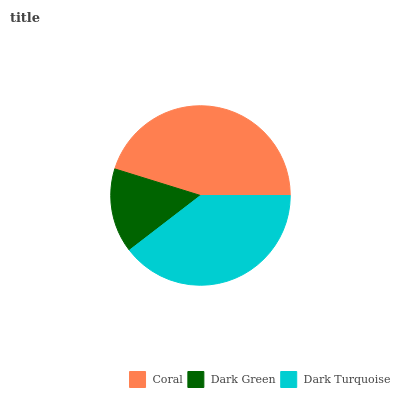Is Dark Green the minimum?
Answer yes or no. Yes. Is Coral the maximum?
Answer yes or no. Yes. Is Dark Turquoise the minimum?
Answer yes or no. No. Is Dark Turquoise the maximum?
Answer yes or no. No. Is Dark Turquoise greater than Dark Green?
Answer yes or no. Yes. Is Dark Green less than Dark Turquoise?
Answer yes or no. Yes. Is Dark Green greater than Dark Turquoise?
Answer yes or no. No. Is Dark Turquoise less than Dark Green?
Answer yes or no. No. Is Dark Turquoise the high median?
Answer yes or no. Yes. Is Dark Turquoise the low median?
Answer yes or no. Yes. Is Coral the high median?
Answer yes or no. No. Is Coral the low median?
Answer yes or no. No. 